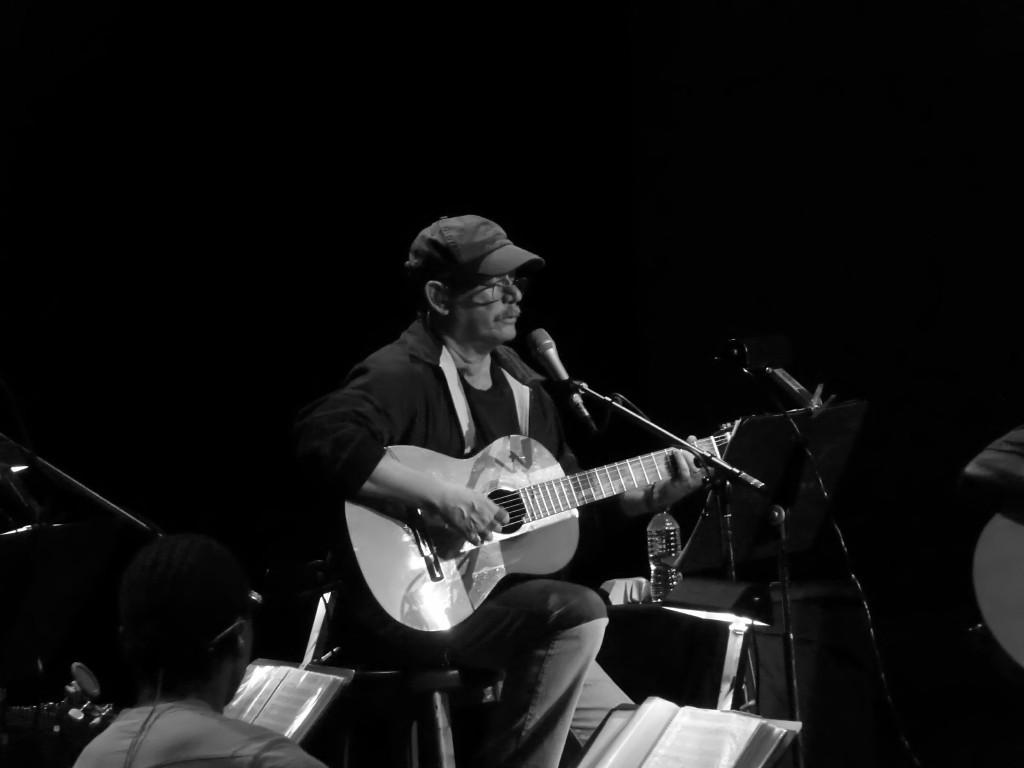Who is the main subject in the image? There is a man in the image. What is the man doing in the image? The man is sitting on a chair and playing a guitar. What other objects can be seen in the image? There is a microphone (mike), a bottle, and a book in the image. What type of locket is the boy wearing in the image? There is no boy or locket present in the image; it features a man playing a guitar. What is the man using to write on the book in the image? There is no pen or writing activity depicted in the image; the man is playing a guitar. 